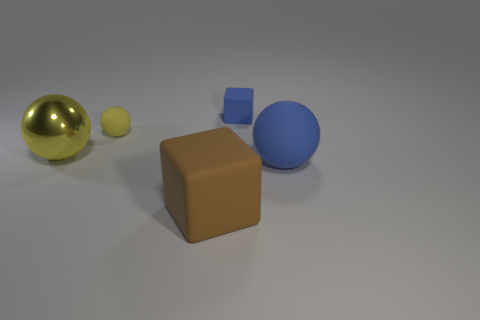Subtract all purple blocks. How many yellow balls are left? 2 Subtract 1 balls. How many balls are left? 2 Add 5 large cyan spheres. How many objects exist? 10 Subtract all big rubber balls. How many balls are left? 2 Subtract all cyan balls. Subtract all red cylinders. How many balls are left? 3 Subtract all balls. How many objects are left? 2 Add 2 big yellow metal cubes. How many big yellow metal cubes exist? 2 Subtract 0 green balls. How many objects are left? 5 Subtract all tiny rubber spheres. Subtract all big metal things. How many objects are left? 3 Add 1 blue rubber spheres. How many blue rubber spheres are left? 2 